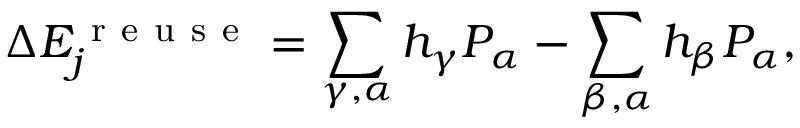Convert formula to latex. <formula><loc_0><loc_0><loc_500><loc_500>\Delta E _ { j } ^ { r e u s e } = \sum _ { \gamma , \alpha } h _ { \gamma } P _ { \alpha } - \sum _ { \beta , \alpha } h _ { \beta } P _ { \alpha } ,</formula> 